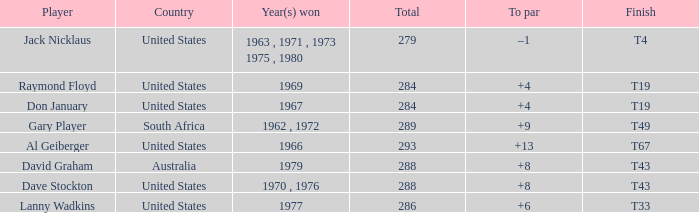What is the average total in 1969? 284.0. Could you help me parse every detail presented in this table? {'header': ['Player', 'Country', 'Year(s) won', 'Total', 'To par', 'Finish'], 'rows': [['Jack Nicklaus', 'United States', '1963 , 1971 , 1973 1975 , 1980', '279', '–1', 'T4'], ['Raymond Floyd', 'United States', '1969', '284', '+4', 'T19'], ['Don January', 'United States', '1967', '284', '+4', 'T19'], ['Gary Player', 'South Africa', '1962 , 1972', '289', '+9', 'T49'], ['Al Geiberger', 'United States', '1966', '293', '+13', 'T67'], ['David Graham', 'Australia', '1979', '288', '+8', 'T43'], ['Dave Stockton', 'United States', '1970 , 1976', '288', '+8', 'T43'], ['Lanny Wadkins', 'United States', '1977', '286', '+6', 'T33']]} 